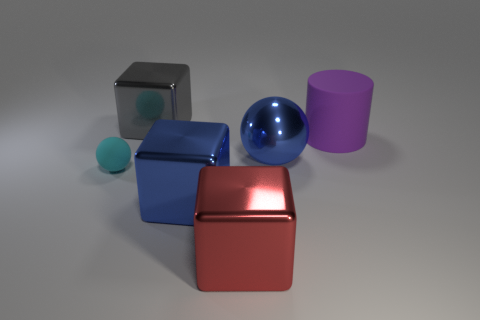Subtract all gray blocks. How many blocks are left? 2 Subtract all cylinders. How many objects are left? 5 Add 1 big blue spheres. How many objects exist? 7 Subtract all large cyan metal cubes. Subtract all big blue metal things. How many objects are left? 4 Add 2 large blue balls. How many large blue balls are left? 3 Add 4 gray metal objects. How many gray metal objects exist? 5 Subtract 1 blue blocks. How many objects are left? 5 Subtract 1 cylinders. How many cylinders are left? 0 Subtract all yellow spheres. Subtract all red cubes. How many spheres are left? 2 Subtract all purple balls. How many gray blocks are left? 1 